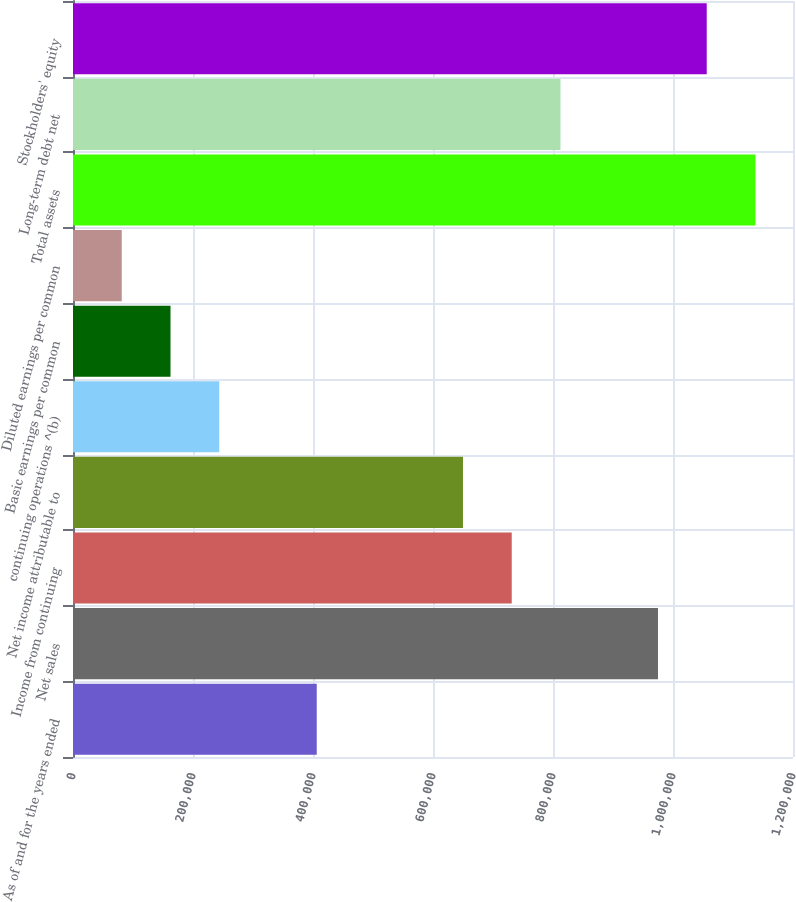Convert chart to OTSL. <chart><loc_0><loc_0><loc_500><loc_500><bar_chart><fcel>As of and for the years ended<fcel>Net sales<fcel>Income from continuing<fcel>Net income attributable to<fcel>continuing operations ^(b)<fcel>Basic earnings per common<fcel>Diluted earnings per common<fcel>Total assets<fcel>Long-term debt net<fcel>Stockholders' equity<nl><fcel>406237<fcel>974966<fcel>731225<fcel>649978<fcel>243743<fcel>162496<fcel>81248.5<fcel>1.13746e+06<fcel>812472<fcel>1.05621e+06<nl></chart> 